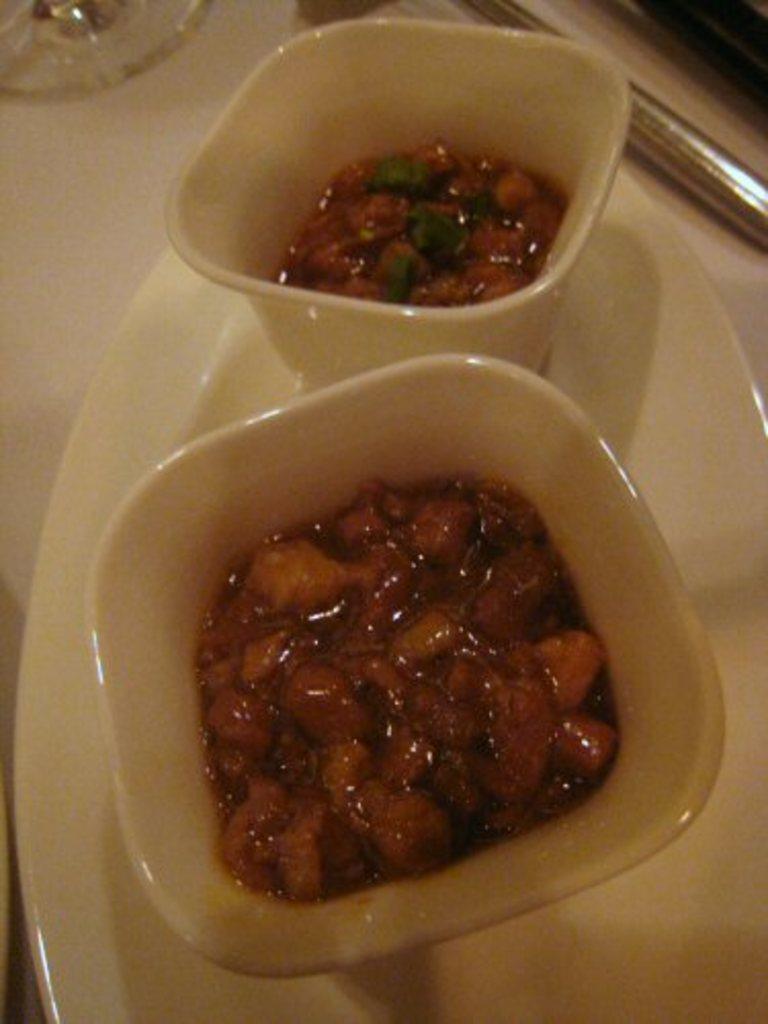How would you summarize this image in a sentence or two? In this picture I can see food items on bowls. These balls are on a white color plate. Here I can see some other objects on a surface. 